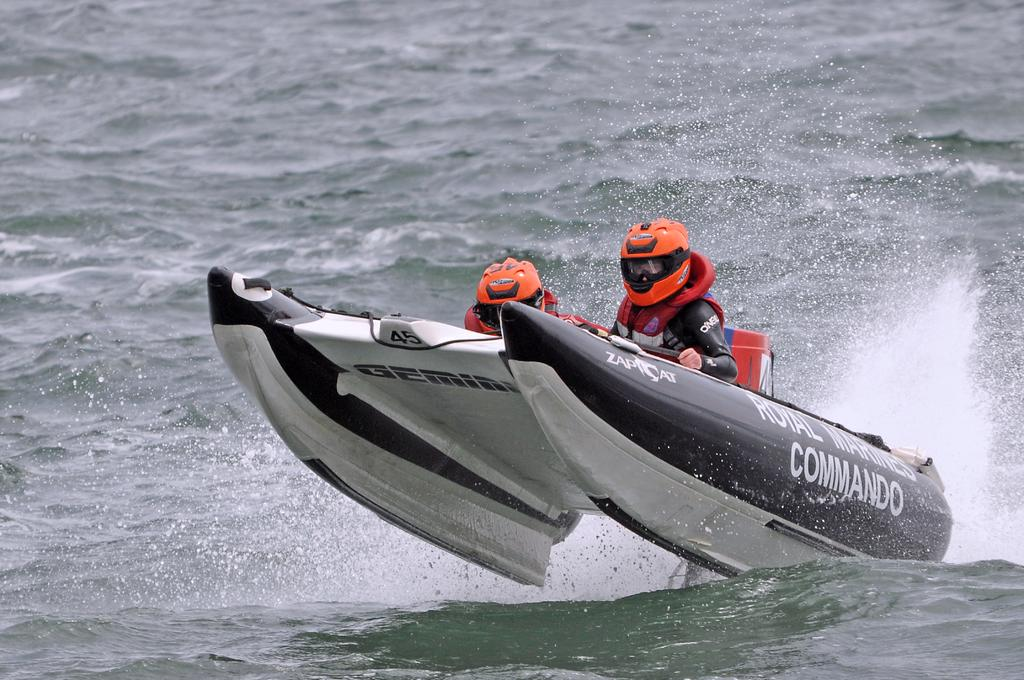<image>
Relay a brief, clear account of the picture shown. Two people in orange helmets are at the front of a boat with the word Commando on the side. 